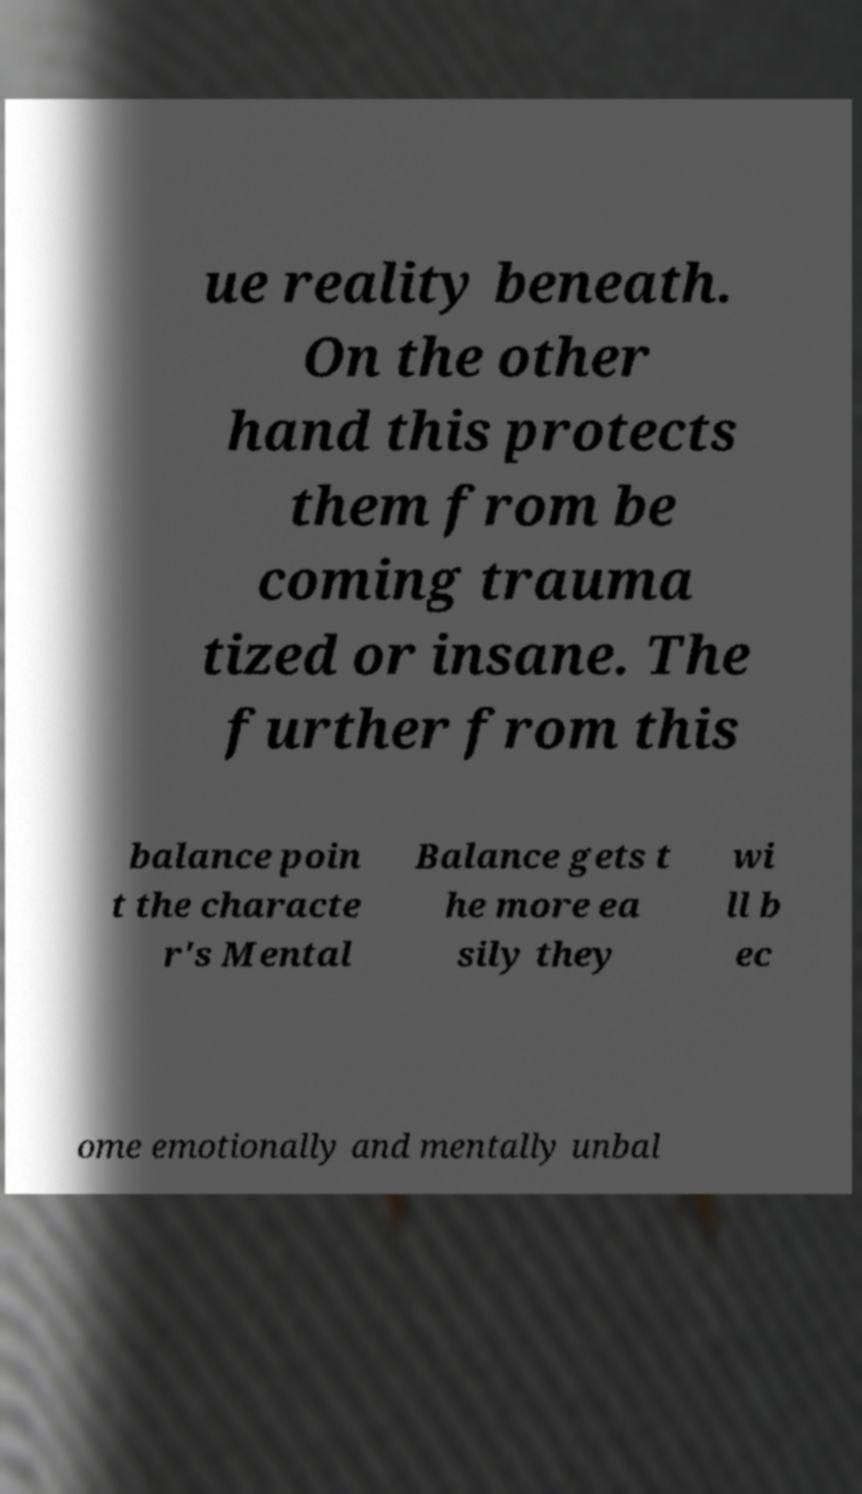Can you accurately transcribe the text from the provided image for me? ue reality beneath. On the other hand this protects them from be coming trauma tized or insane. The further from this balance poin t the characte r's Mental Balance gets t he more ea sily they wi ll b ec ome emotionally and mentally unbal 